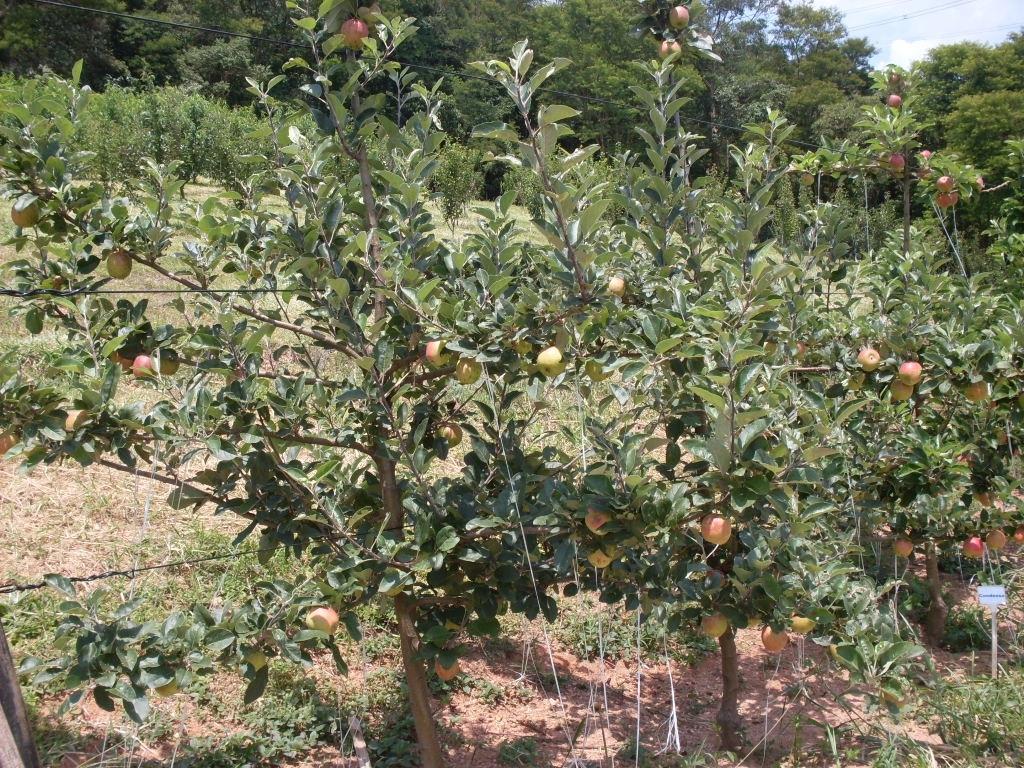Describe this image in one or two sentences. In this image we can see the trees with fruits. In the background, we can see the trees and the sky. 